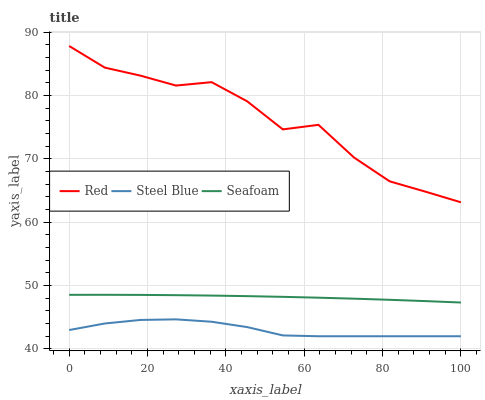Does Steel Blue have the minimum area under the curve?
Answer yes or no. Yes. Does Red have the maximum area under the curve?
Answer yes or no. Yes. Does Seafoam have the minimum area under the curve?
Answer yes or no. No. Does Seafoam have the maximum area under the curve?
Answer yes or no. No. Is Seafoam the smoothest?
Answer yes or no. Yes. Is Red the roughest?
Answer yes or no. Yes. Is Red the smoothest?
Answer yes or no. No. Is Seafoam the roughest?
Answer yes or no. No. Does Steel Blue have the lowest value?
Answer yes or no. Yes. Does Seafoam have the lowest value?
Answer yes or no. No. Does Red have the highest value?
Answer yes or no. Yes. Does Seafoam have the highest value?
Answer yes or no. No. Is Seafoam less than Red?
Answer yes or no. Yes. Is Red greater than Seafoam?
Answer yes or no. Yes. Does Seafoam intersect Red?
Answer yes or no. No. 